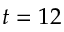<formula> <loc_0><loc_0><loc_500><loc_500>t = 1 2</formula> 